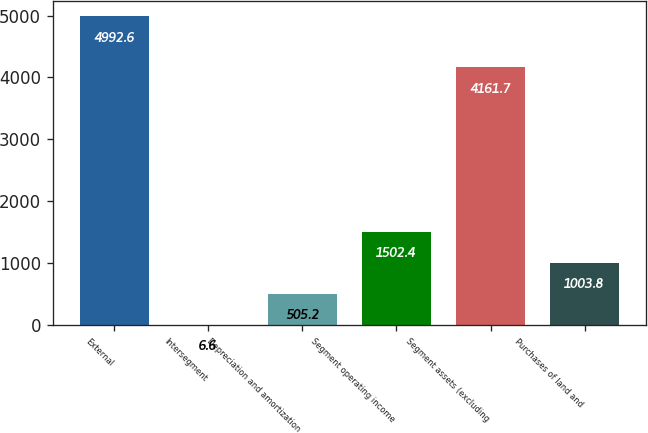Convert chart to OTSL. <chart><loc_0><loc_0><loc_500><loc_500><bar_chart><fcel>External<fcel>Intersegment<fcel>Depreciation and amortization<fcel>Segment operating income<fcel>Segment assets (excluding<fcel>Purchases of land and<nl><fcel>4992.6<fcel>6.6<fcel>505.2<fcel>1502.4<fcel>4161.7<fcel>1003.8<nl></chart> 